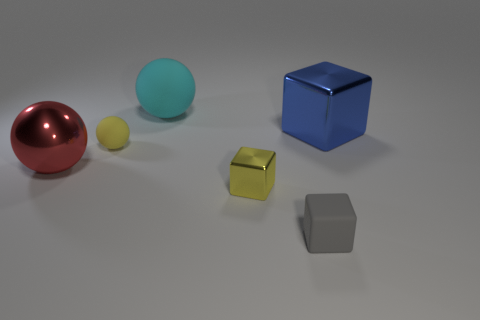Add 3 large yellow rubber things. How many objects exist? 9 Add 5 big balls. How many big balls are left? 7 Add 3 matte cubes. How many matte cubes exist? 4 Subtract 1 cyan spheres. How many objects are left? 5 Subtract all tiny shiny cylinders. Subtract all tiny blocks. How many objects are left? 4 